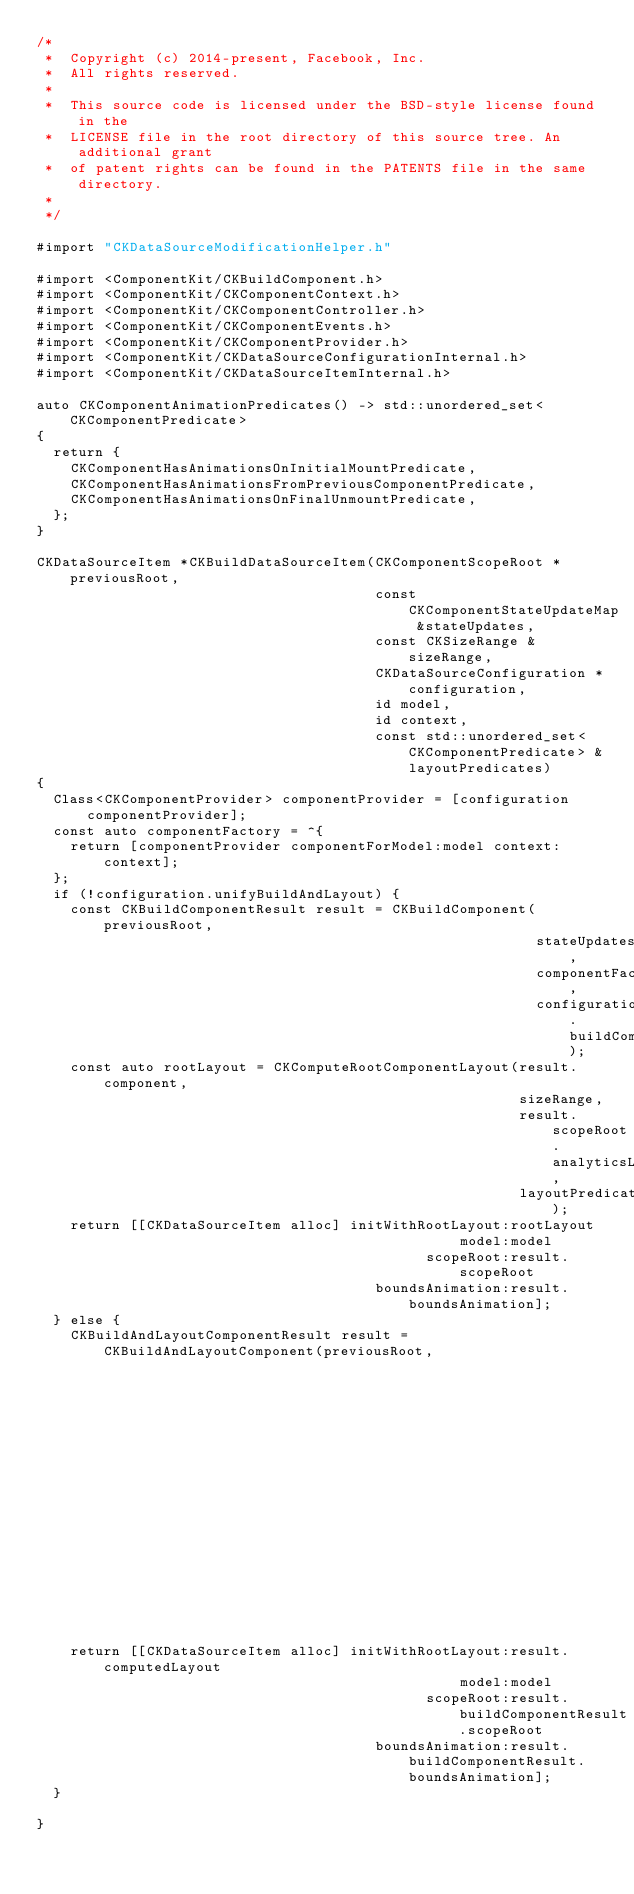<code> <loc_0><loc_0><loc_500><loc_500><_ObjectiveC_>/*
 *  Copyright (c) 2014-present, Facebook, Inc.
 *  All rights reserved.
 *
 *  This source code is licensed under the BSD-style license found in the
 *  LICENSE file in the root directory of this source tree. An additional grant
 *  of patent rights can be found in the PATENTS file in the same directory.
 *
 */

#import "CKDataSourceModificationHelper.h"

#import <ComponentKit/CKBuildComponent.h>
#import <ComponentKit/CKComponentContext.h>
#import <ComponentKit/CKComponentController.h>
#import <ComponentKit/CKComponentEvents.h>
#import <ComponentKit/CKComponentProvider.h>
#import <ComponentKit/CKDataSourceConfigurationInternal.h>
#import <ComponentKit/CKDataSourceItemInternal.h>

auto CKComponentAnimationPredicates() -> std::unordered_set<CKComponentPredicate>
{
  return {
    CKComponentHasAnimationsOnInitialMountPredicate,
    CKComponentHasAnimationsFromPreviousComponentPredicate,
    CKComponentHasAnimationsOnFinalUnmountPredicate,
  };
}

CKDataSourceItem *CKBuildDataSourceItem(CKComponentScopeRoot *previousRoot,
                                        const CKComponentStateUpdateMap &stateUpdates,
                                        const CKSizeRange &sizeRange,
                                        CKDataSourceConfiguration *configuration,
                                        id model,
                                        id context,
                                        const std::unordered_set<CKComponentPredicate> &layoutPredicates)
{
  Class<CKComponentProvider> componentProvider = [configuration componentProvider];
  const auto componentFactory = ^{
    return [componentProvider componentForModel:model context:context];
  };
  if (!configuration.unifyBuildAndLayout) {
    const CKBuildComponentResult result = CKBuildComponent(previousRoot,
                                                           stateUpdates,
                                                           componentFactory,
                                                           configuration.buildComponentConfig);
    const auto rootLayout = CKComputeRootComponentLayout(result.component,
                                                         sizeRange,
                                                         result.scopeRoot.analyticsListener,
                                                         layoutPredicates);
    return [[CKDataSourceItem alloc] initWithRootLayout:rootLayout
                                                  model:model
                                              scopeRoot:result.scopeRoot
                                        boundsAnimation:result.boundsAnimation];
  } else {
    CKBuildAndLayoutComponentResult result = CKBuildAndLayoutComponent(previousRoot,
                                                                       stateUpdates,
                                                                       sizeRange,
                                                                       componentFactory,
                                                                       layoutPredicates,
                                                                       configuration.buildComponentConfig);
    return [[CKDataSourceItem alloc] initWithRootLayout:result.computedLayout
                                                  model:model
                                              scopeRoot:result.buildComponentResult.scopeRoot
                                        boundsAnimation:result.buildComponentResult.boundsAnimation];
  }

}
</code> 